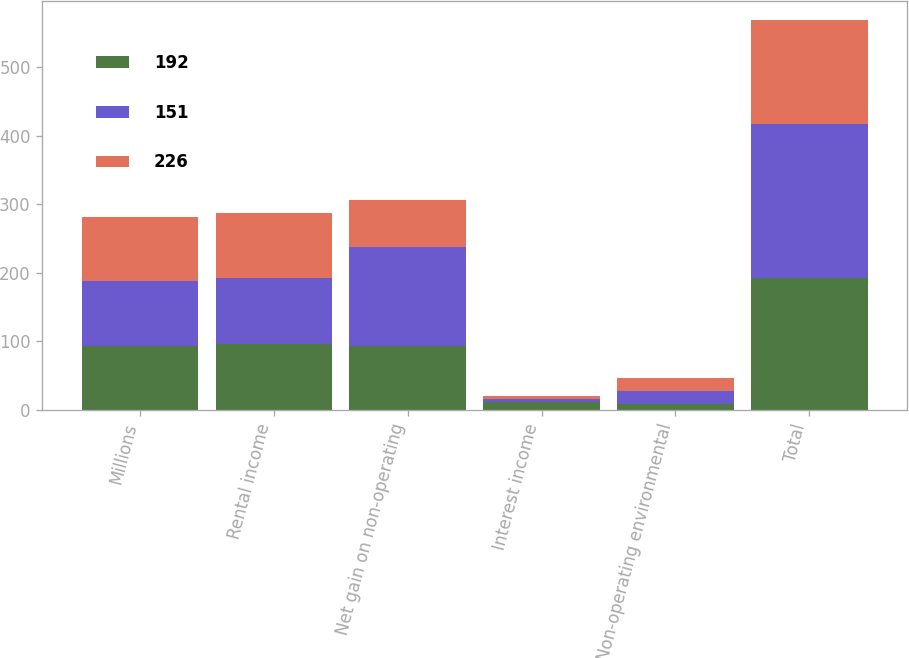Convert chart to OTSL. <chart><loc_0><loc_0><loc_500><loc_500><stacked_bar_chart><ecel><fcel>Millions<fcel>Rental income<fcel>Net gain on non-operating<fcel>Interest income<fcel>Non-operating environmental<fcel>Total<nl><fcel>192<fcel>94<fcel>96<fcel>94<fcel>11<fcel>9<fcel>192<nl><fcel>151<fcel>94<fcel>96<fcel>144<fcel>5<fcel>19<fcel>226<nl><fcel>226<fcel>94<fcel>96<fcel>69<fcel>4<fcel>18<fcel>151<nl></chart> 